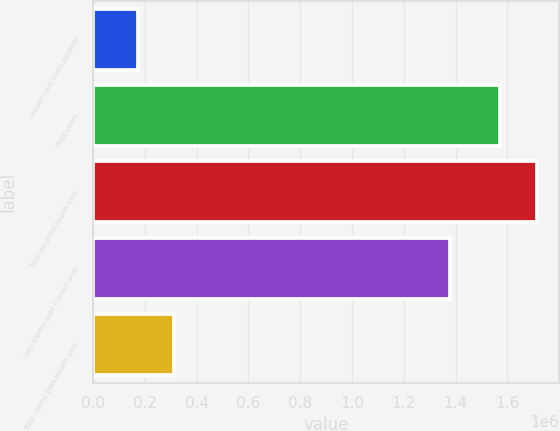<chart> <loc_0><loc_0><loc_500><loc_500><bar_chart><fcel>Health care costs payable<fcel>Prior years<fcel>Total incurred health care<fcel>Less Claims paid Current year<fcel>Total claims paid Health care<nl><fcel>172310<fcel>1.57272e+06<fcel>1.71311e+06<fcel>1.37814e+06<fcel>312694<nl></chart> 